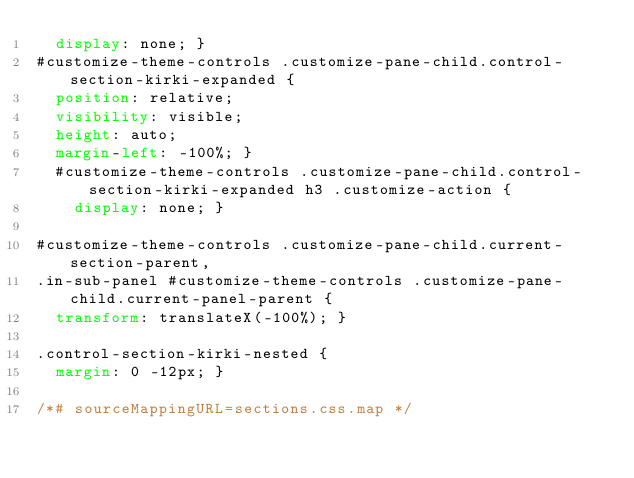<code> <loc_0><loc_0><loc_500><loc_500><_CSS_>  display: none; }
#customize-theme-controls .customize-pane-child.control-section-kirki-expanded {
  position: relative;
  visibility: visible;
  height: auto;
  margin-left: -100%; }
  #customize-theme-controls .customize-pane-child.control-section-kirki-expanded h3 .customize-action {
    display: none; }

#customize-theme-controls .customize-pane-child.current-section-parent,
.in-sub-panel #customize-theme-controls .customize-pane-child.current-panel-parent {
  transform: translateX(-100%); }

.control-section-kirki-nested {
  margin: 0 -12px; }

/*# sourceMappingURL=sections.css.map */
</code> 